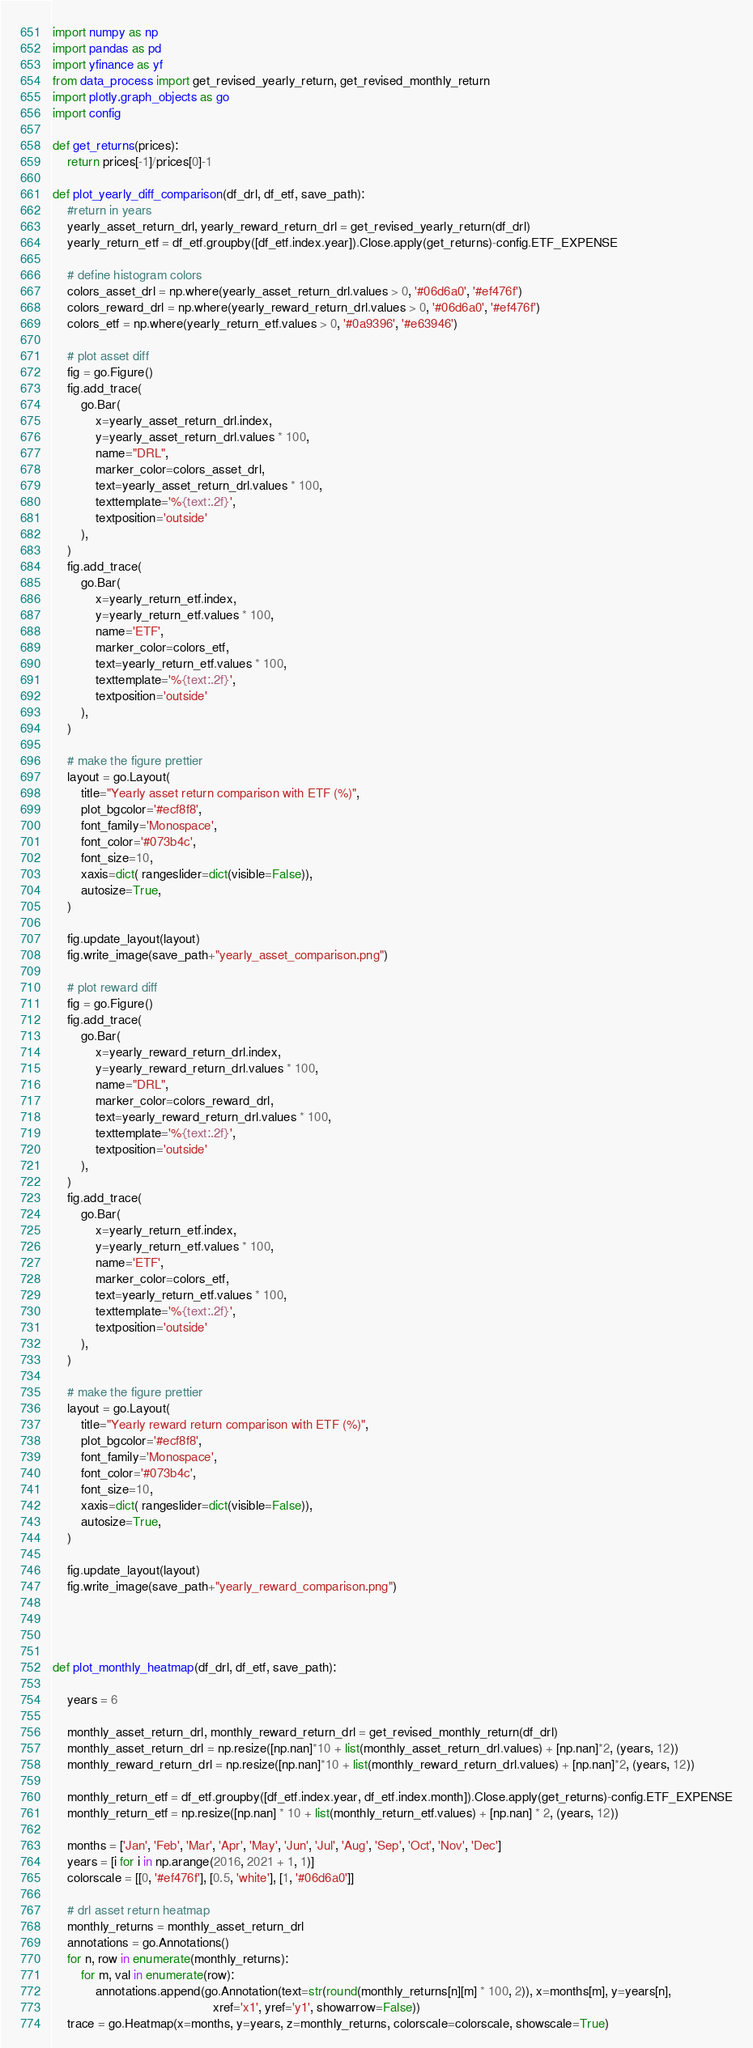Convert code to text. <code><loc_0><loc_0><loc_500><loc_500><_Python_>import numpy as np
import pandas as pd
import yfinance as yf
from data_process import get_revised_yearly_return, get_revised_monthly_return
import plotly.graph_objects as go
import config

def get_returns(prices):
    return prices[-1]/prices[0]-1

def plot_yearly_diff_comparison(df_drl, df_etf, save_path):
    #return in years
    yearly_asset_return_drl, yearly_reward_return_drl = get_revised_yearly_return(df_drl)
    yearly_return_etf = df_etf.groupby([df_etf.index.year]).Close.apply(get_returns)-config.ETF_EXPENSE

    # define histogram colors
    colors_asset_drl = np.where(yearly_asset_return_drl.values > 0, '#06d6a0', '#ef476f')
    colors_reward_drl = np.where(yearly_reward_return_drl.values > 0, '#06d6a0', '#ef476f')
    colors_etf = np.where(yearly_return_etf.values > 0, '#0a9396', '#e63946')

    # plot asset diff
    fig = go.Figure()
    fig.add_trace(
        go.Bar(
            x=yearly_asset_return_drl.index,
            y=yearly_asset_return_drl.values * 100,
            name="DRL",
            marker_color=colors_asset_drl,
            text=yearly_asset_return_drl.values * 100,
            texttemplate='%{text:.2f}',
            textposition='outside'
        ),
    )
    fig.add_trace(
        go.Bar(
            x=yearly_return_etf.index,
            y=yearly_return_etf.values * 100,
            name='ETF',
            marker_color=colors_etf,
            text=yearly_return_etf.values * 100,
            texttemplate='%{text:.2f}',
            textposition='outside'
        ),
    )

    # make the figure prettier
    layout = go.Layout(
        title="Yearly asset return comparison with ETF (%)",
        plot_bgcolor='#ecf8f8',
        font_family='Monospace',
        font_color='#073b4c',
        font_size=10,
        xaxis=dict( rangeslider=dict(visible=False)),
        autosize=True,
    )

    fig.update_layout(layout)
    fig.write_image(save_path+"yearly_asset_comparison.png")
    
    # plot reward diff
    fig = go.Figure()
    fig.add_trace(
        go.Bar(
            x=yearly_reward_return_drl.index,
            y=yearly_reward_return_drl.values * 100,
            name="DRL",
            marker_color=colors_reward_drl,
            text=yearly_reward_return_drl.values * 100,
            texttemplate='%{text:.2f}',
            textposition='outside'
        ),
    )
    fig.add_trace(
        go.Bar(
            x=yearly_return_etf.index,
            y=yearly_return_etf.values * 100,
            name='ETF',
            marker_color=colors_etf,
            text=yearly_return_etf.values * 100,
            texttemplate='%{text:.2f}',
            textposition='outside'
        ),
    )

    # make the figure prettier
    layout = go.Layout(
        title="Yearly reward return comparison with ETF (%)",
        plot_bgcolor='#ecf8f8',
        font_family='Monospace',
        font_color='#073b4c',
        font_size=10,
        xaxis=dict( rangeslider=dict(visible=False)),
        autosize=True,
    )

    fig.update_layout(layout)
    fig.write_image(save_path+"yearly_reward_comparison.png")
    
    
    

def plot_monthly_heatmap(df_drl, df_etf, save_path):
    
    years = 6
    
    monthly_asset_return_drl, monthly_reward_return_drl = get_revised_monthly_return(df_drl)
    monthly_asset_return_drl = np.resize([np.nan]*10 + list(monthly_asset_return_drl.values) + [np.nan]*2, (years, 12))
    monthly_reward_return_drl = np.resize([np.nan]*10 + list(monthly_reward_return_drl.values) + [np.nan]*2, (years, 12))

    monthly_return_etf = df_etf.groupby([df_etf.index.year, df_etf.index.month]).Close.apply(get_returns)-config.ETF_EXPENSE
    monthly_return_etf = np.resize([np.nan] * 10 + list(monthly_return_etf.values) + [np.nan] * 2, (years, 12))

    months = ['Jan', 'Feb', 'Mar', 'Apr', 'May', 'Jun', 'Jul', 'Aug', 'Sep', 'Oct', 'Nov', 'Dec']
    years = [i for i in np.arange(2016, 2021 + 1, 1)]
    colorscale = [[0, '#ef476f'], [0.5, 'white'], [1, '#06d6a0']]

    # drl asset return heatmap
    monthly_returns = monthly_asset_return_drl
    annotations = go.Annotations()
    for n, row in enumerate(monthly_returns):
        for m, val in enumerate(row):
            annotations.append(go.Annotation(text=str(round(monthly_returns[n][m] * 100, 2)), x=months[m], y=years[n],
                                             xref='x1', yref='y1', showarrow=False))
    trace = go.Heatmap(x=months, y=years, z=monthly_returns, colorscale=colorscale, showscale=True)</code> 